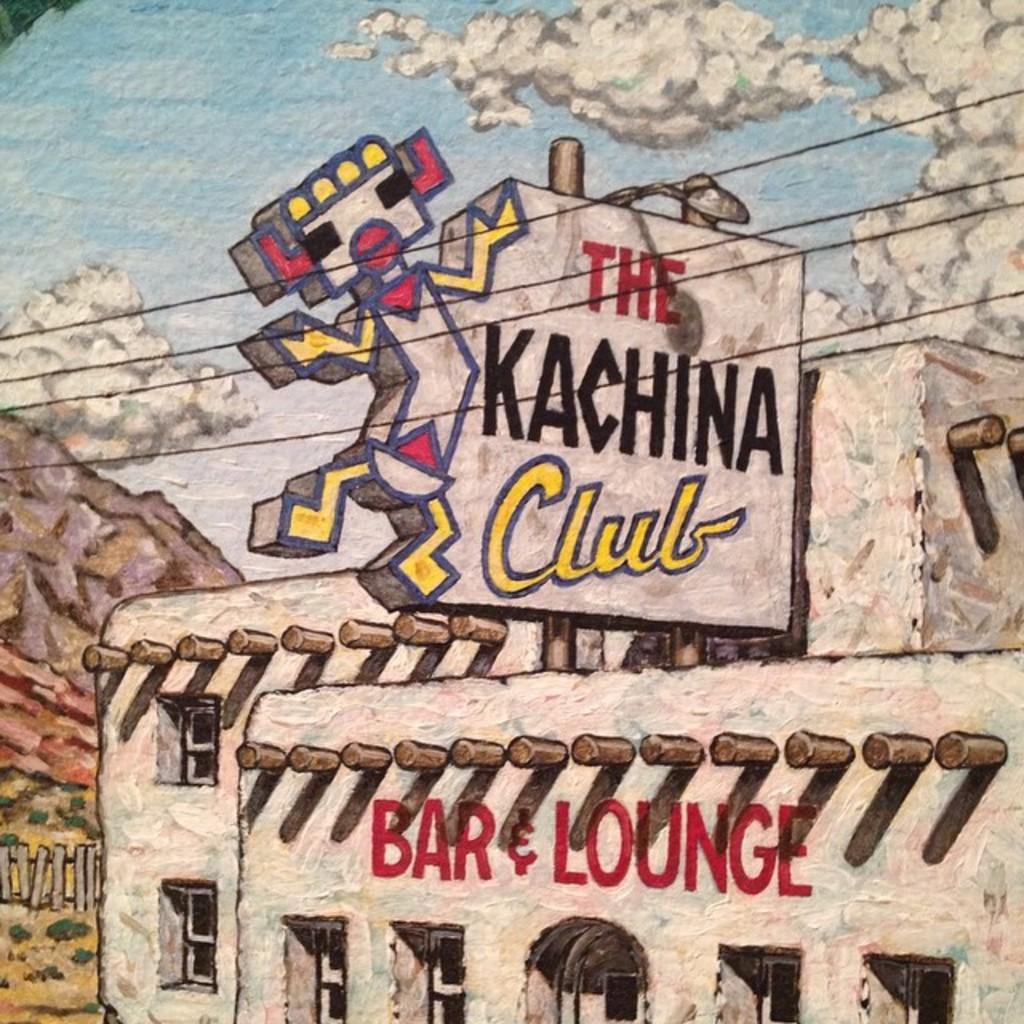Can you describe this image briefly? In this picture i can see painting of building, sky and trees. 